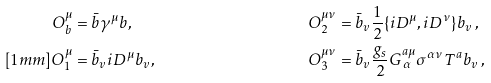Convert formula to latex. <formula><loc_0><loc_0><loc_500><loc_500>O _ { b } ^ { \mu } & = \bar { b } \gamma ^ { \mu } b , & O _ { 2 } ^ { \mu \nu } & = \bar { b } _ { v } \frac { 1 } { 2 } \{ i D ^ { \mu } , i D ^ { \nu } \} b _ { v } \, , & & & \\ [ 1 m m ] O _ { 1 } ^ { \mu } & = \bar { b } _ { v } i D ^ { \mu } b _ { v } , & O _ { 3 } ^ { \mu \nu } & = \bar { b } _ { v } \frac { g _ { s } } { 2 } G ^ { a \mu } _ { \, \alpha } \sigma ^ { \alpha \nu } T ^ { a } b _ { v } \, , & & &</formula> 